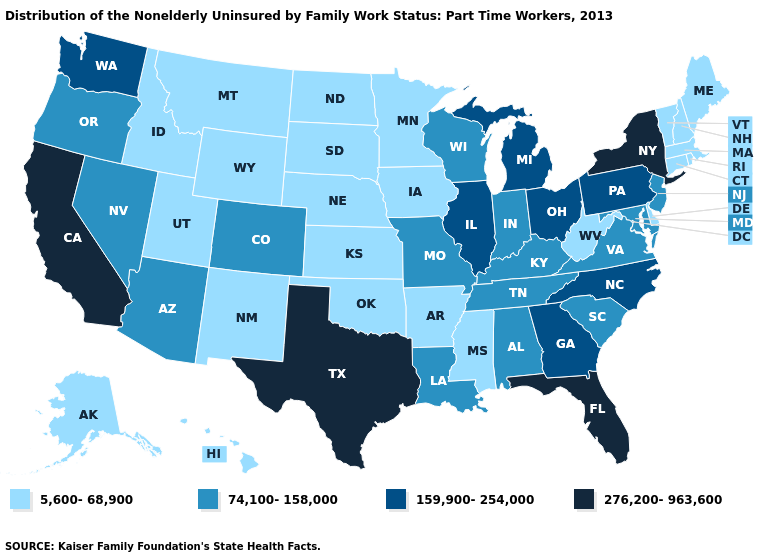Which states have the lowest value in the USA?
Give a very brief answer. Alaska, Arkansas, Connecticut, Delaware, Hawaii, Idaho, Iowa, Kansas, Maine, Massachusetts, Minnesota, Mississippi, Montana, Nebraska, New Hampshire, New Mexico, North Dakota, Oklahoma, Rhode Island, South Dakota, Utah, Vermont, West Virginia, Wyoming. What is the value of Indiana?
Keep it brief. 74,100-158,000. Name the states that have a value in the range 159,900-254,000?
Concise answer only. Georgia, Illinois, Michigan, North Carolina, Ohio, Pennsylvania, Washington. Does California have a lower value than Louisiana?
Give a very brief answer. No. Among the states that border Minnesota , which have the lowest value?
Answer briefly. Iowa, North Dakota, South Dakota. What is the value of Virginia?
Answer briefly. 74,100-158,000. Does Virginia have a lower value than New Mexico?
Answer briefly. No. Does the map have missing data?
Quick response, please. No. Does Ohio have the lowest value in the MidWest?
Keep it brief. No. Does Texas have the highest value in the USA?
Answer briefly. Yes. Does Nebraska have the lowest value in the MidWest?
Short answer required. Yes. What is the value of Alabama?
Be succinct. 74,100-158,000. Among the states that border Florida , which have the lowest value?
Short answer required. Alabama. Name the states that have a value in the range 276,200-963,600?
Answer briefly. California, Florida, New York, Texas. 